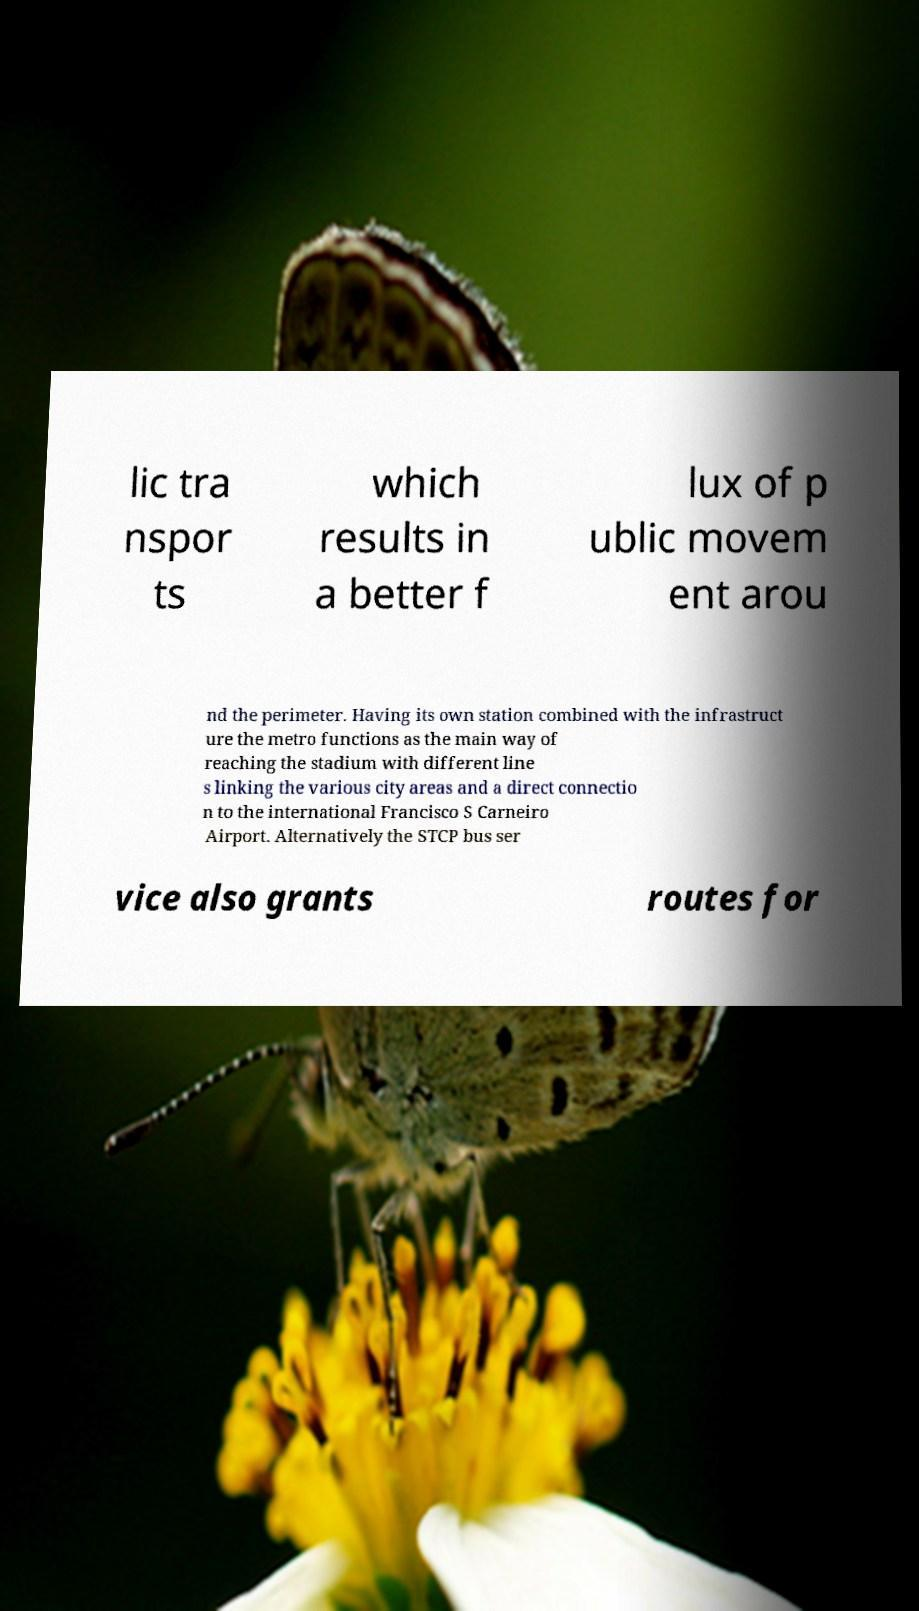Please identify and transcribe the text found in this image. lic tra nspor ts which results in a better f lux of p ublic movem ent arou nd the perimeter. Having its own station combined with the infrastruct ure the metro functions as the main way of reaching the stadium with different line s linking the various city areas and a direct connectio n to the international Francisco S Carneiro Airport. Alternatively the STCP bus ser vice also grants routes for 